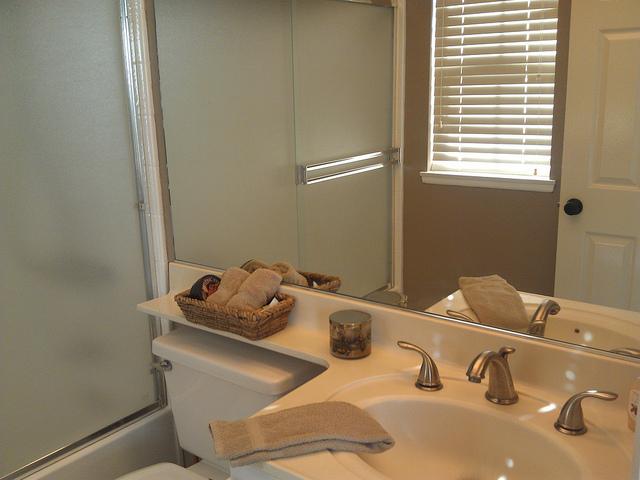What is covering the window?
Write a very short answer. Blinds. What room is this?
Answer briefly. Bathroom. What is in the basket?
Short answer required. Towels. 